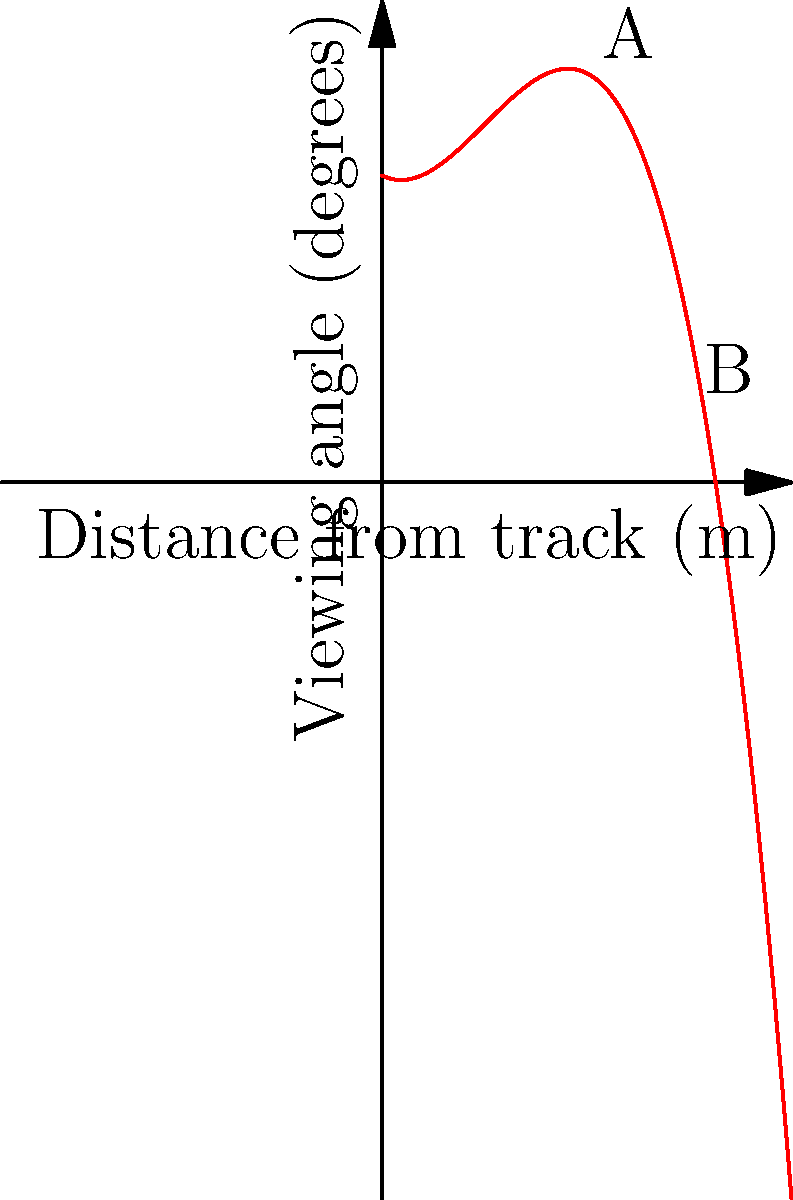At a drift competition, the viewing angle for spectators can be modeled by the function $f(x) = -0.005x^3 + 0.15x^2 - 0.5x + 30$, where $x$ is the distance from the track in meters and $f(x)$ is the viewing angle in degrees. Two VIP sections, A and B, are located at 20 meters and 30 meters from the track, respectively. What is the difference in viewing angles between these two sections? To solve this problem, we need to follow these steps:

1. Calculate the viewing angle for section A:
   $f(20) = -0.005(20)^3 + 0.15(20)^2 - 0.5(20) + 30$
   $= -0.005(8000) + 0.15(400) - 10 + 30$
   $= -40 + 60 - 10 + 30$
   $= 40$ degrees

2. Calculate the viewing angle for section B:
   $f(30) = -0.005(30)^3 + 0.15(30)^2 - 0.5(30) + 30$
   $= -0.005(27000) + 0.15(900) - 15 + 30$
   $= -135 + 135 - 15 + 30$
   $= 15$ degrees

3. Calculate the difference between the viewing angles:
   Difference = Viewing angle A - Viewing angle B
   $= 40 - 15 = 25$ degrees

Therefore, the difference in viewing angles between sections A and B is 25 degrees.
Answer: 25 degrees 